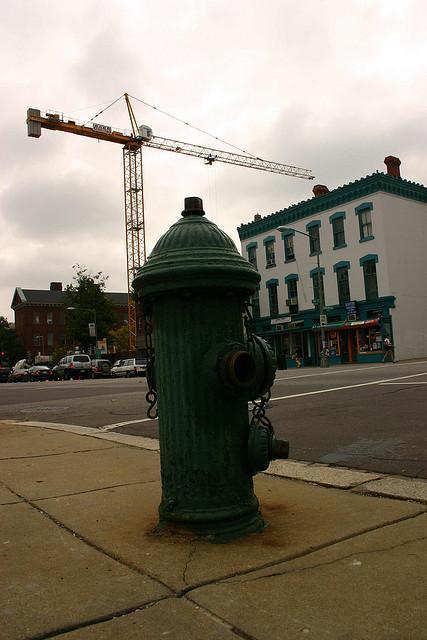How many pizza pan do you see?
Give a very brief answer. 0. 